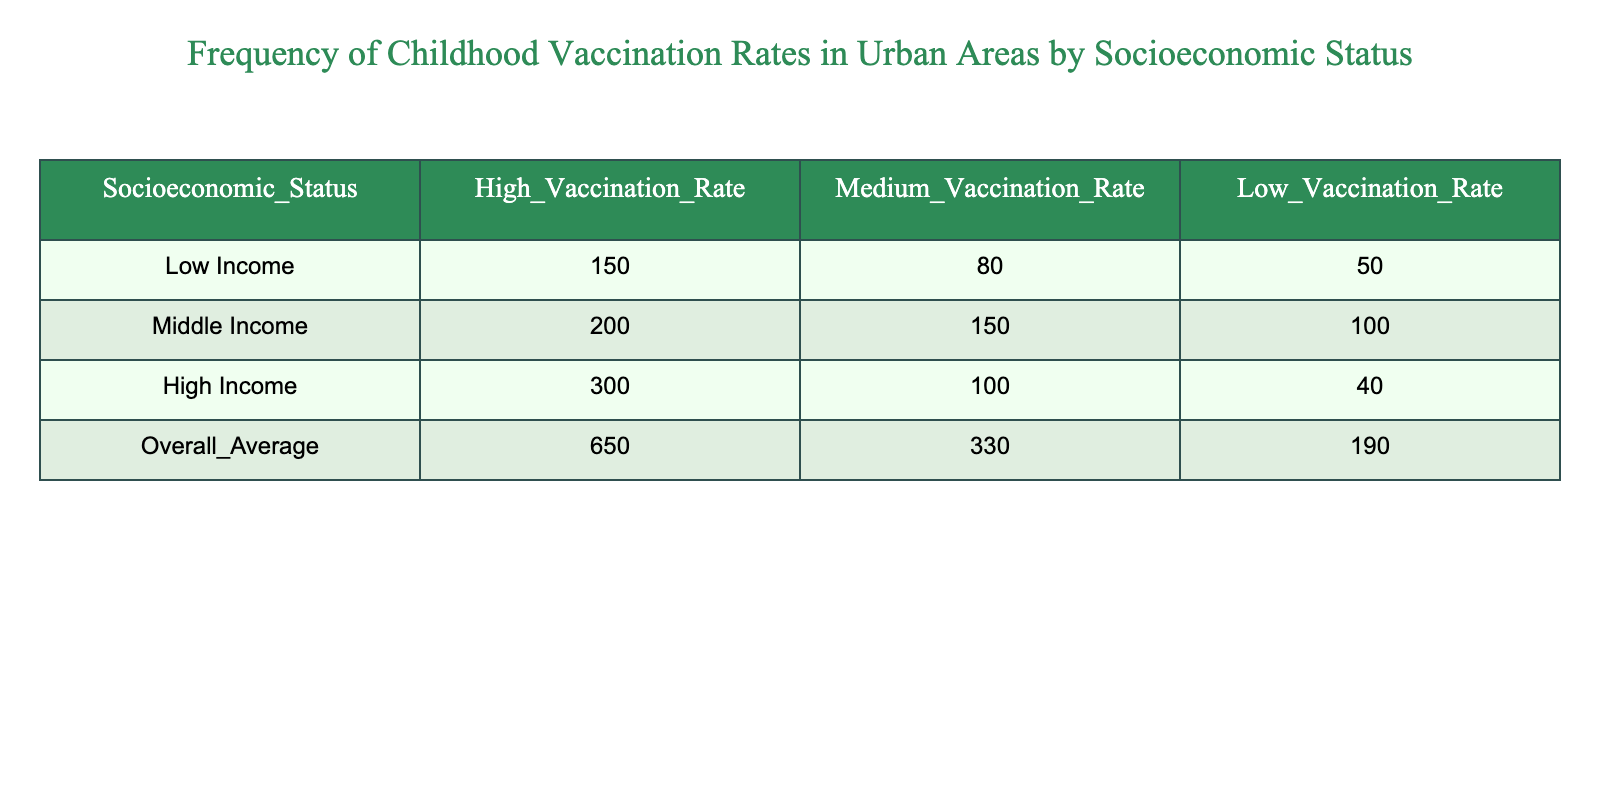What is the high vaccination rate for low-income children? The table indicates that the high vaccination rate for low-income children is listed as 150.
Answer: 150 How many children from middle-income families have a low vaccination rate? According to the table, the low vaccination rate for middle-income families is 100.
Answer: 100 What is the total number of children from all socioeconomic statuses with medium vaccination rates? To find the total, sum the medium vaccination rates across the three socioeconomic statuses: 80 (low income) + 150 (middle income) + 100 (high income) = 330.
Answer: 330 Is the high vaccination rate among high-income children greater than the combined high vaccination rates of low-income and middle-income children? The high vaccination rate for high-income children is 300, while the combined high vaccination rates for low and middle income are 150 + 200 = 350, which means 300 is less than 350. Thus, the statement is false.
Answer: No What is the difference in the number of children with low vaccination rates between low income and high income? The low vaccination rate for low-income children is 50, and for high-income children it is 40. The difference is calculated as 50 - 40 = 10.
Answer: 10 What fraction of the total high vaccination rate comes from middle-income children? The total high vaccination rate is 650, and the contribution from middle-income children is 200. The fraction is 200/650, which simplifies to 4/13.
Answer: 4/13 How many more children have high vaccination rates in high-income areas compared to medium vaccination rates in low-income areas? The high vaccination rate in high-income areas is 300 and the medium vaccination rate in low-income areas is 80. The difference is 300 - 80 = 220.
Answer: 220 What is the overall average for high vaccination rates across all socioeconomic statuses? The overall average for high vaccination rates, as stated in the table, is 650.
Answer: 650 Are there more children with a medium vaccination rate than those with a low vaccination rate in middle-income families? In middle-income families, the medium vaccination rate is 150 and the low vaccination rate is 100. Since 150 is greater than 100, the statement is true.
Answer: Yes 